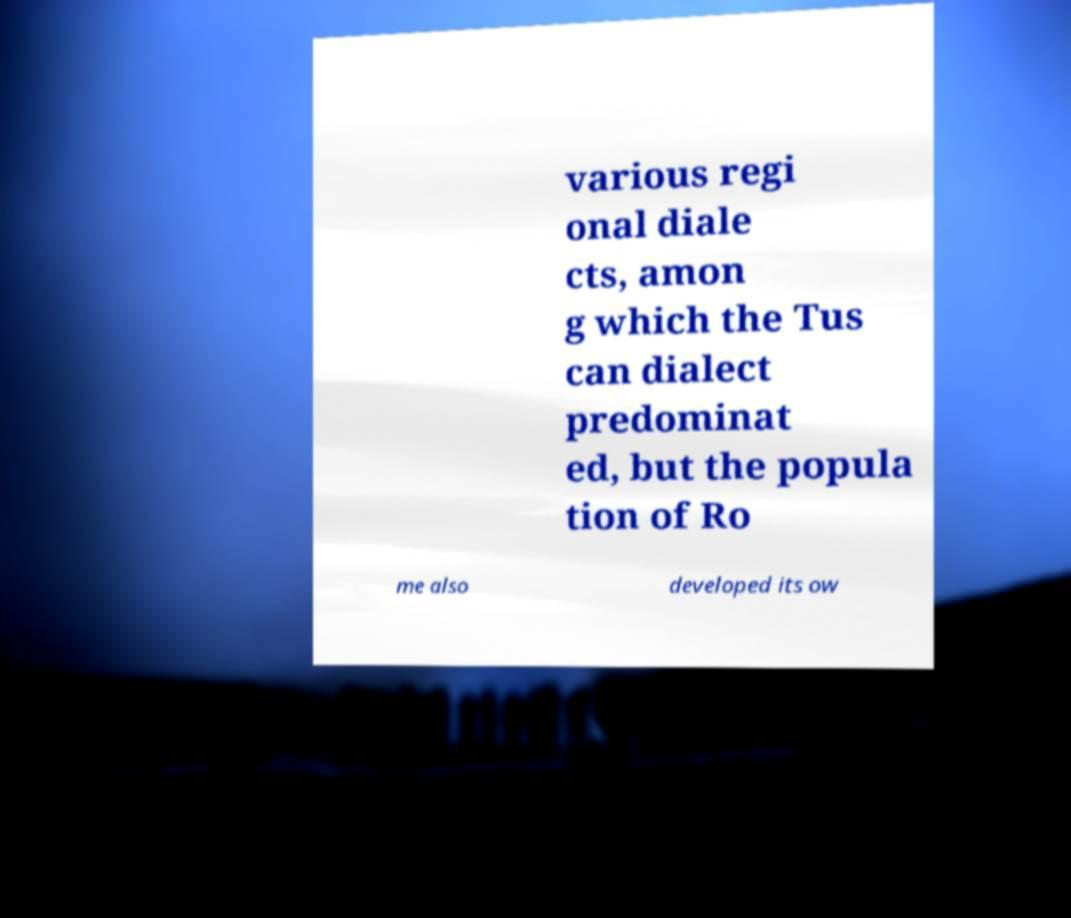I need the written content from this picture converted into text. Can you do that? various regi onal diale cts, amon g which the Tus can dialect predominat ed, but the popula tion of Ro me also developed its ow 